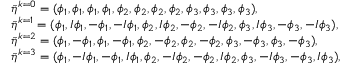Convert formula to latex. <formula><loc_0><loc_0><loc_500><loc_500>\begin{array} { r l } & { \bar { \eta } ^ { k = 0 } = ( \phi _ { 1 } , \phi _ { 1 } , \phi _ { 1 } , \phi _ { 1 } , \phi _ { 2 } , \phi _ { 2 } , \phi _ { 2 } , \phi _ { 2 } , \phi _ { 3 } , \phi _ { 3 } , \phi _ { 3 } , \phi _ { 3 } ) , } \\ & { \bar { \eta } ^ { k = 1 } = ( \phi _ { 1 } , I \phi _ { 1 } , - \phi _ { 1 } , - I \phi _ { 1 } , \phi _ { 2 } , I \phi _ { 2 } , - \phi _ { 2 } , - I \phi _ { 2 } , \phi _ { 3 } , I \phi _ { 3 } , - \phi _ { 3 } , - I \phi _ { 3 } ) , } \\ & { \bar { \eta } ^ { k = 2 } = ( \phi _ { 1 } , - \phi _ { 1 } , \phi _ { 1 } , - \phi _ { 1 } , \phi _ { 2 } , - \phi _ { 2 } , \phi _ { 2 } , - \phi _ { 2 } , \phi _ { 3 } , - \phi _ { 3 } , \phi _ { 3 } , - \phi _ { 3 } ) , } \\ & { \bar { \eta } ^ { k = 3 } = ( \phi _ { 1 } , - I \phi _ { 1 } , - \phi _ { 1 } , I \phi _ { 1 } , \phi _ { 2 } , - I \phi _ { 2 } , - \phi _ { 2 } , I \phi _ { 2 } , \phi _ { 3 } , - I \phi _ { 3 } , - \phi _ { 3 } , I \phi _ { 3 } ) , } \end{array}</formula> 